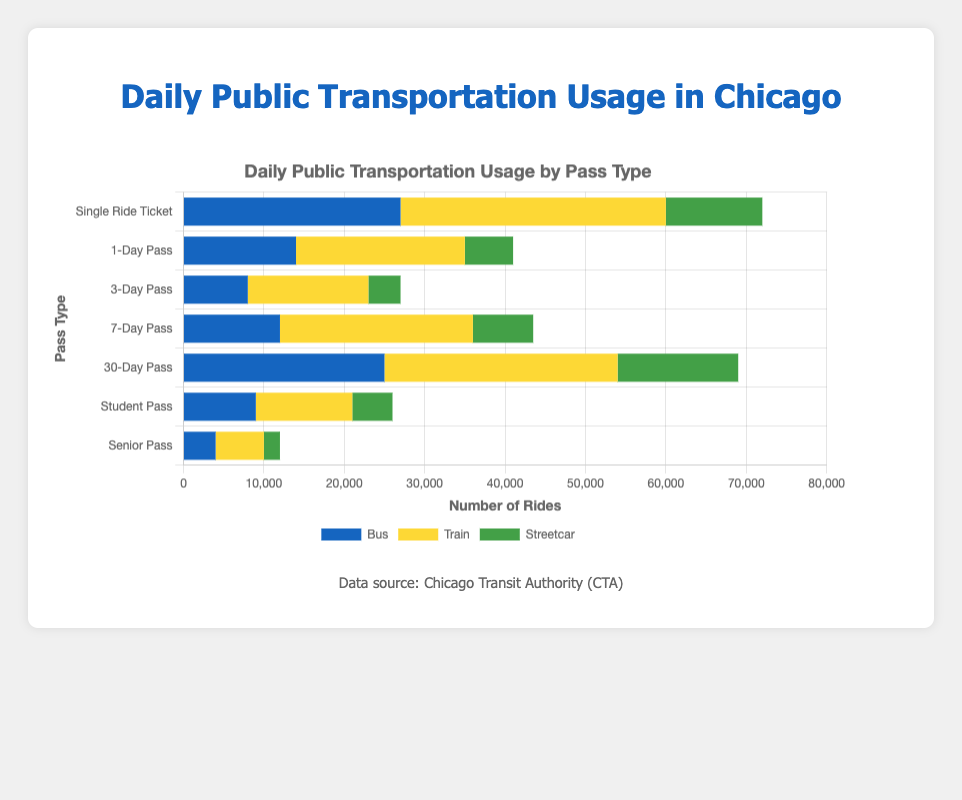Which pass type accounts for the highest number of total daily rides? Sum the bus, train, and streetcar rides for each pass and compare. The 30-Day Pass has the highest number with (25000 + 29000 + 15000 = 69000) rides.
Answer: 30-Day Pass What is the total number of daily bus rides for all pass types combined? Sum the bus rides across all pass types: 27000 + 14000 + 8000 + 12000 + 25000 + 9000 + 4000 = 99000.
Answer: 99000 Which mode of transportation has the least total daily usage across all pass types? Sum the daily usage of bus, train, and streetcar across all pass types. Streetcar has the least usage with (12000+6000+4000+7500+15000+5000+2000=51500).
Answer: Streetcar Which pass type has the highest number of daily train rides? Compare the number of train rides for each pass type; the 30-Day Pass has the highest with 29000 train rides.
Answer: 30-Day Pass What is the combined number of daily rides (bus and train) for Single Ride Tickets? Add the bus and train rides for Single Ride Tickets: 27000 (bus) + 33000 (train) = 60000.
Answer: 60000 How does the number of daily streetcar rides for 7-Day Pass compare to that for 1-Day Pass? Compare the numbers: 7-Day Pass has 7500 streetcar rides, while 1-Day Pass has 6000. 7-Day Pass has more.
Answer: 7-Day Pass has more Which pass type has the least daily bus usage? Compare the bus usage across all pass types; the Senior Pass has the least with 4000 bus rides.
Answer: Senior Pass Compare the total daily rides (bus, train, streetcar) for Student Pass and Senior Pass. Sum the rides for each pass: Student Pass (9000 + 12000 + 5000 = 26000) vs. Senior Pass (4000 + 6000 + 2000 = 12000); Student Pass has more.
Answer: Student Pass has more Which transport type has the most significant difference in usage between 1-Day Pass and 3-Day Pass? Calculate the absolute differences: Bus (14000-8000=6000), Train (21000-15000=6000), Streetcar (6000-4000=2000). Bus and train have the largest differences.
Answer: Bus and Train What is the difference between the total number of daily bus rides and train rides across all pass types? Sum bus and train rides separately: Bus (99000), Train (139000). Difference = 139000 - 99000 = 40000.
Answer: 40000 Which mode of transportation for the 7-Day Pass is used more frequently, bus or streetcar? Compare the number of rides: Bus (12000) vs. Streetcar (7500). The bus is used more frequently.
Answer: Bus 